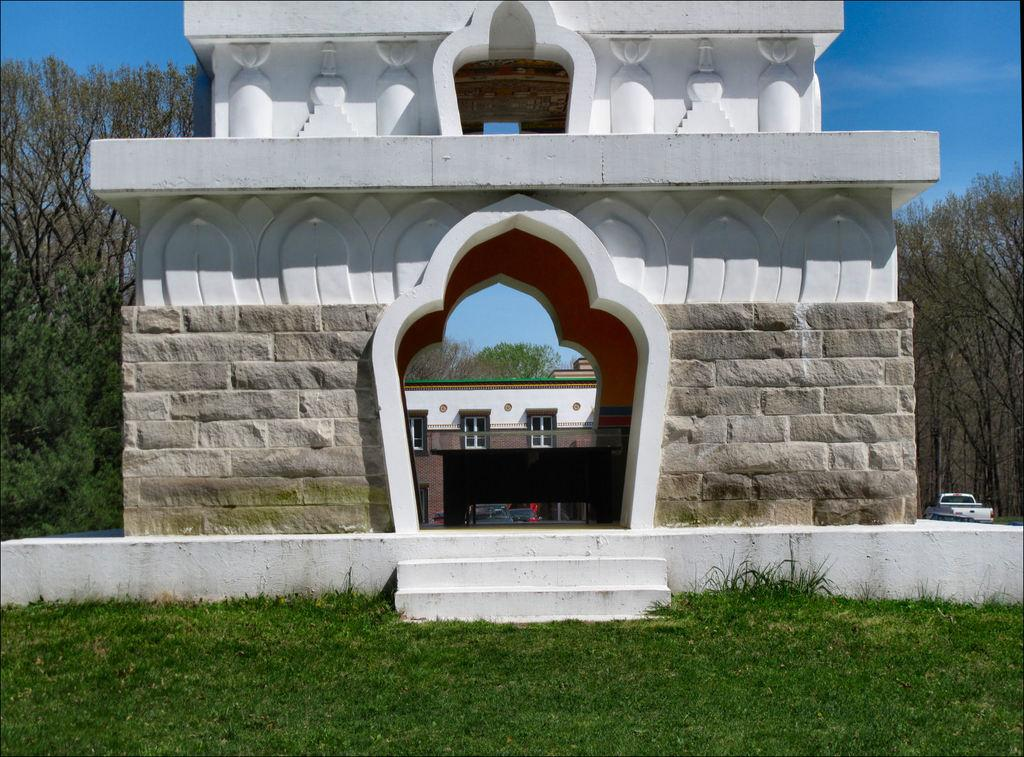What structure is located in the center of the image? There is an arch in the center of the image. What type of vegetation can be seen in the image? There is grass in the image. What is visible in the background of the image? The sky, clouds, trees, and at least one building are visible in the background of the image. What type of furniture can be seen in the image? There is no furniture present in the image. How many tomatoes are growing on the trees in the background of the image? There are no tomatoes visible in the image, as the trees in the background are not fruit-bearing trees. 